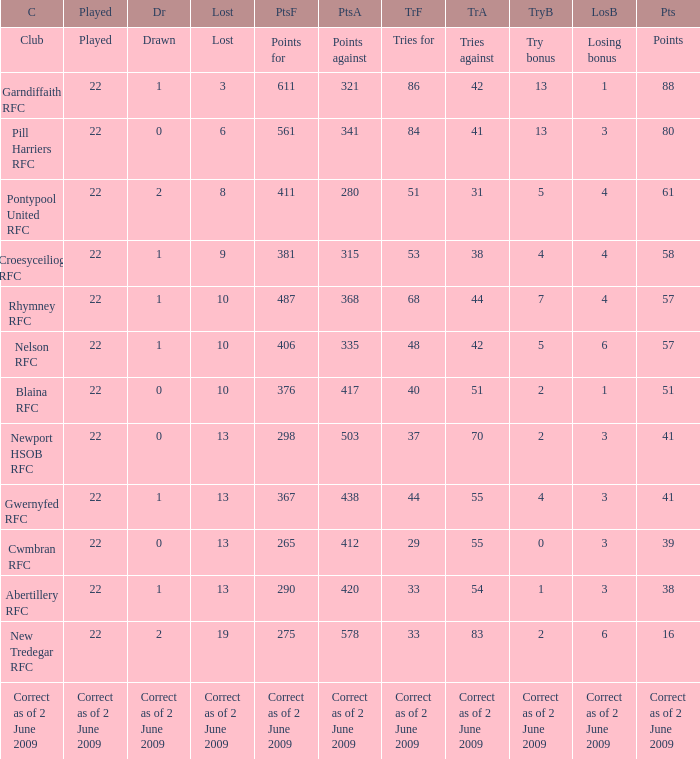Which club has 40 tries for? Blaina RFC. 